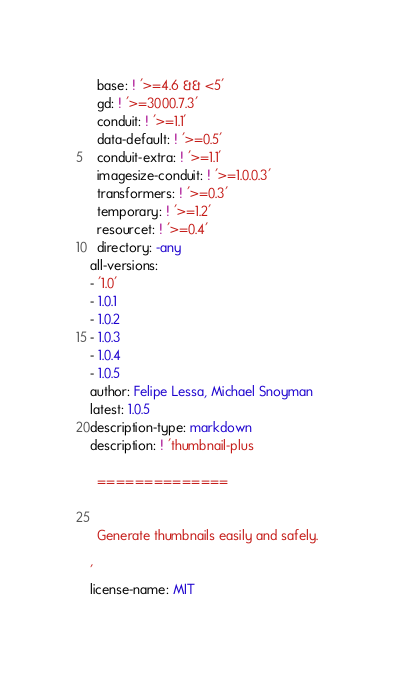<code> <loc_0><loc_0><loc_500><loc_500><_YAML_>  base: ! '>=4.6 && <5'
  gd: ! '>=3000.7.3'
  conduit: ! '>=1.1'
  data-default: ! '>=0.5'
  conduit-extra: ! '>=1.1'
  imagesize-conduit: ! '>=1.0.0.3'
  transformers: ! '>=0.3'
  temporary: ! '>=1.2'
  resourcet: ! '>=0.4'
  directory: -any
all-versions:
- '1.0'
- 1.0.1
- 1.0.2
- 1.0.3
- 1.0.4
- 1.0.5
author: Felipe Lessa, Michael Snoyman
latest: 1.0.5
description-type: markdown
description: ! 'thumbnail-plus

  ==============


  Generate thumbnails easily and safely.

'
license-name: MIT
</code> 